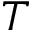<formula> <loc_0><loc_0><loc_500><loc_500>T</formula> 